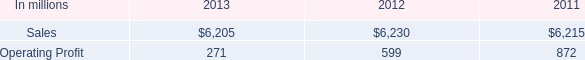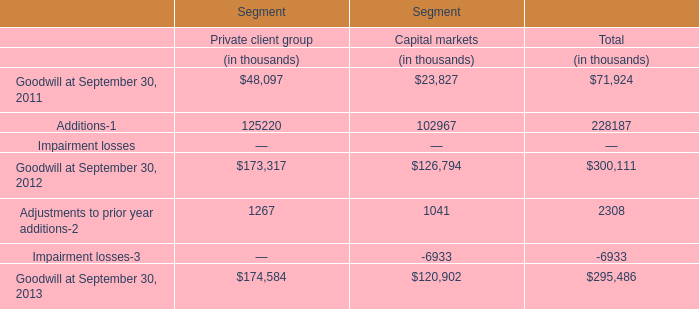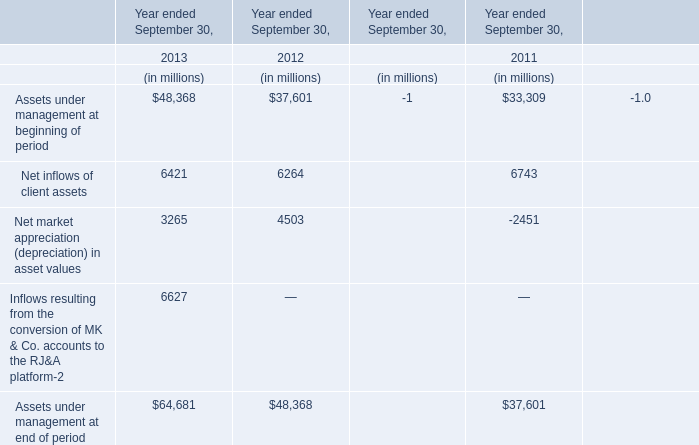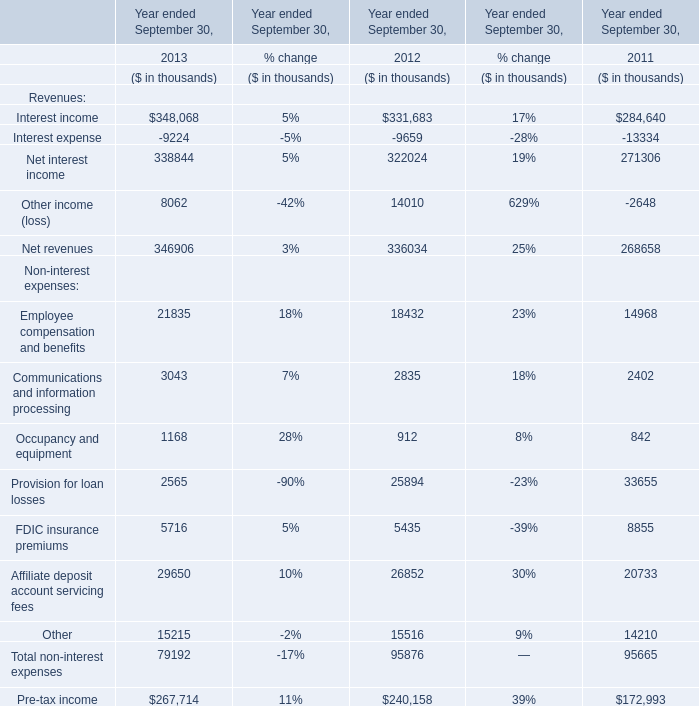what is the highest total amount of Net revenues? 
Answer: 2013. 